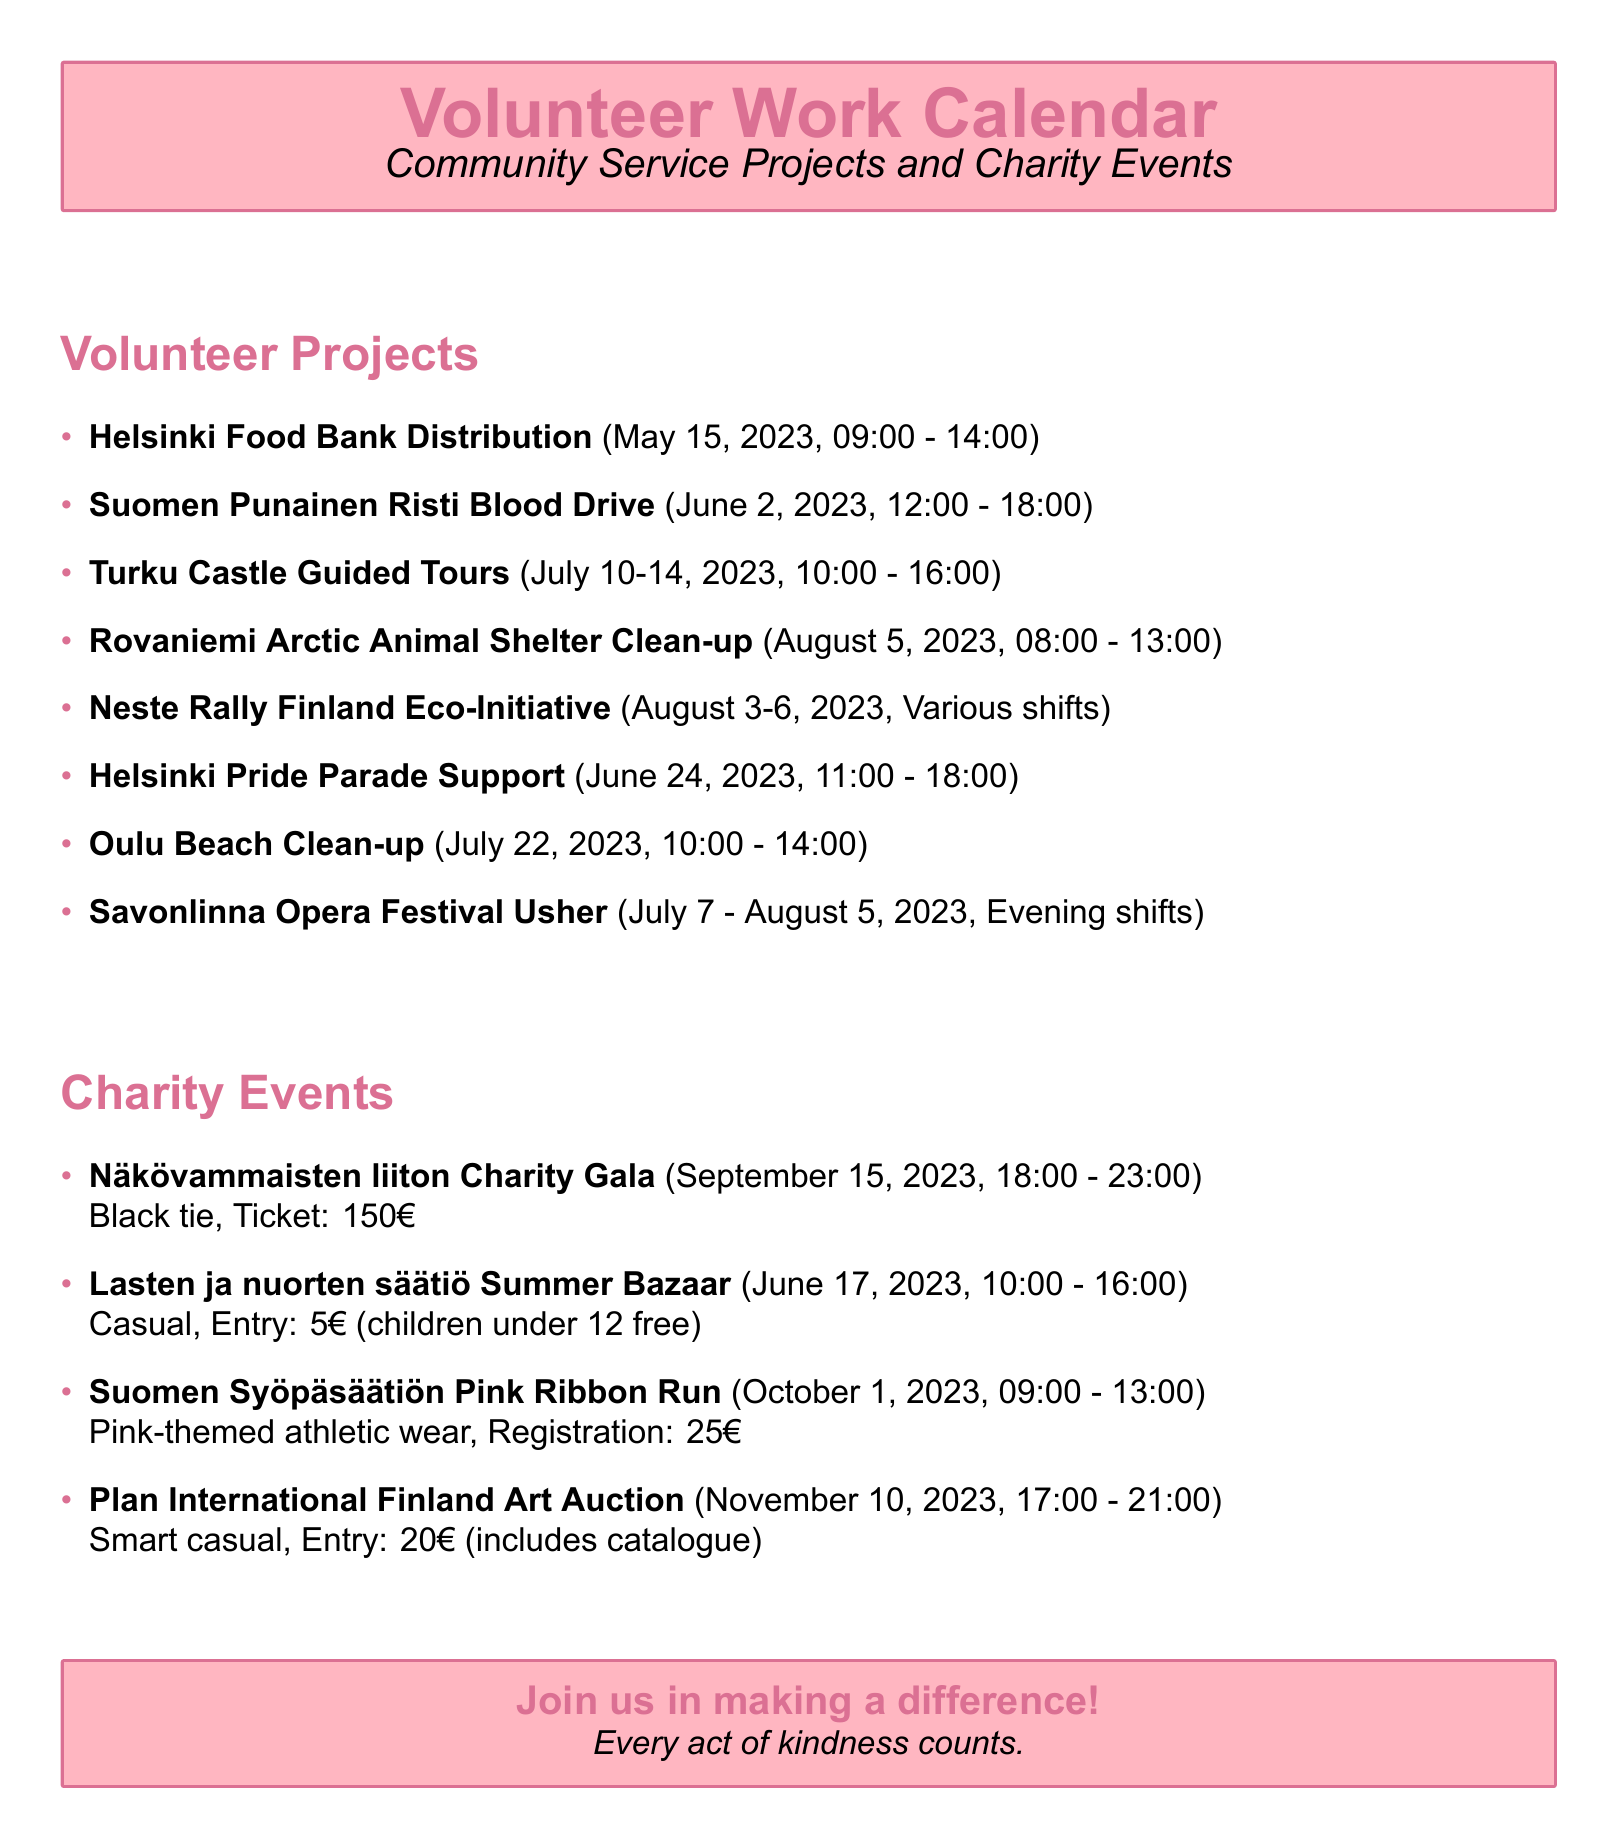what date is the Helsinki Food Bank Distribution scheduled for? The date of the Helsinki Food Bank Distribution is mentioned clearly in the document.
Answer: May 15, 2023 what organization is hosting the Suomen Punainen Risti Blood Drive? The document states the organization responsible for the Blood Drive event.
Answer: Finnish Red Cross how long will the Turku Castle Guided Tours take place? The duration of the Turku Castle Guided Tours is provided in the document, specifying the start and end date.
Answer: July 10 to July 14, 2023 what is the dress code for the Näkövammaisten liiton Charity Gala? The document clearly states the required dress code for the charity gala event.
Answer: Black tie how much is the ticket price for the Plan International Finland Art Auction? The ticket price for the Art Auction is mentioned directly in the document.
Answer: 20€ which project requires skills in customer service and teamwork? This question involves reasoning about required skills for specific events listed in the document.
Answer: Neste Rally Finland Eco-Initiative what is the location of the Oulu Beach Clean-up? The location of the Oulu Beach Clean-up event is specifically stated in the document.
Answer: Nallikari Beach, 90510 Oulu how many charity events are listed in the document? The document provides a count of charity events detailed within.
Answer: Four who will benefit from the funds raised at the Lasten ja nuorten säätiö Summer Bazaar? This requires combining information about the event and its purpose provided in the document.
Answer: Youth programs when does the Suomen Syöpäsäätiön Pink Ribbon Run start? The document specifies the starting time of the Pink Ribbon Run event.
Answer: 09:00 